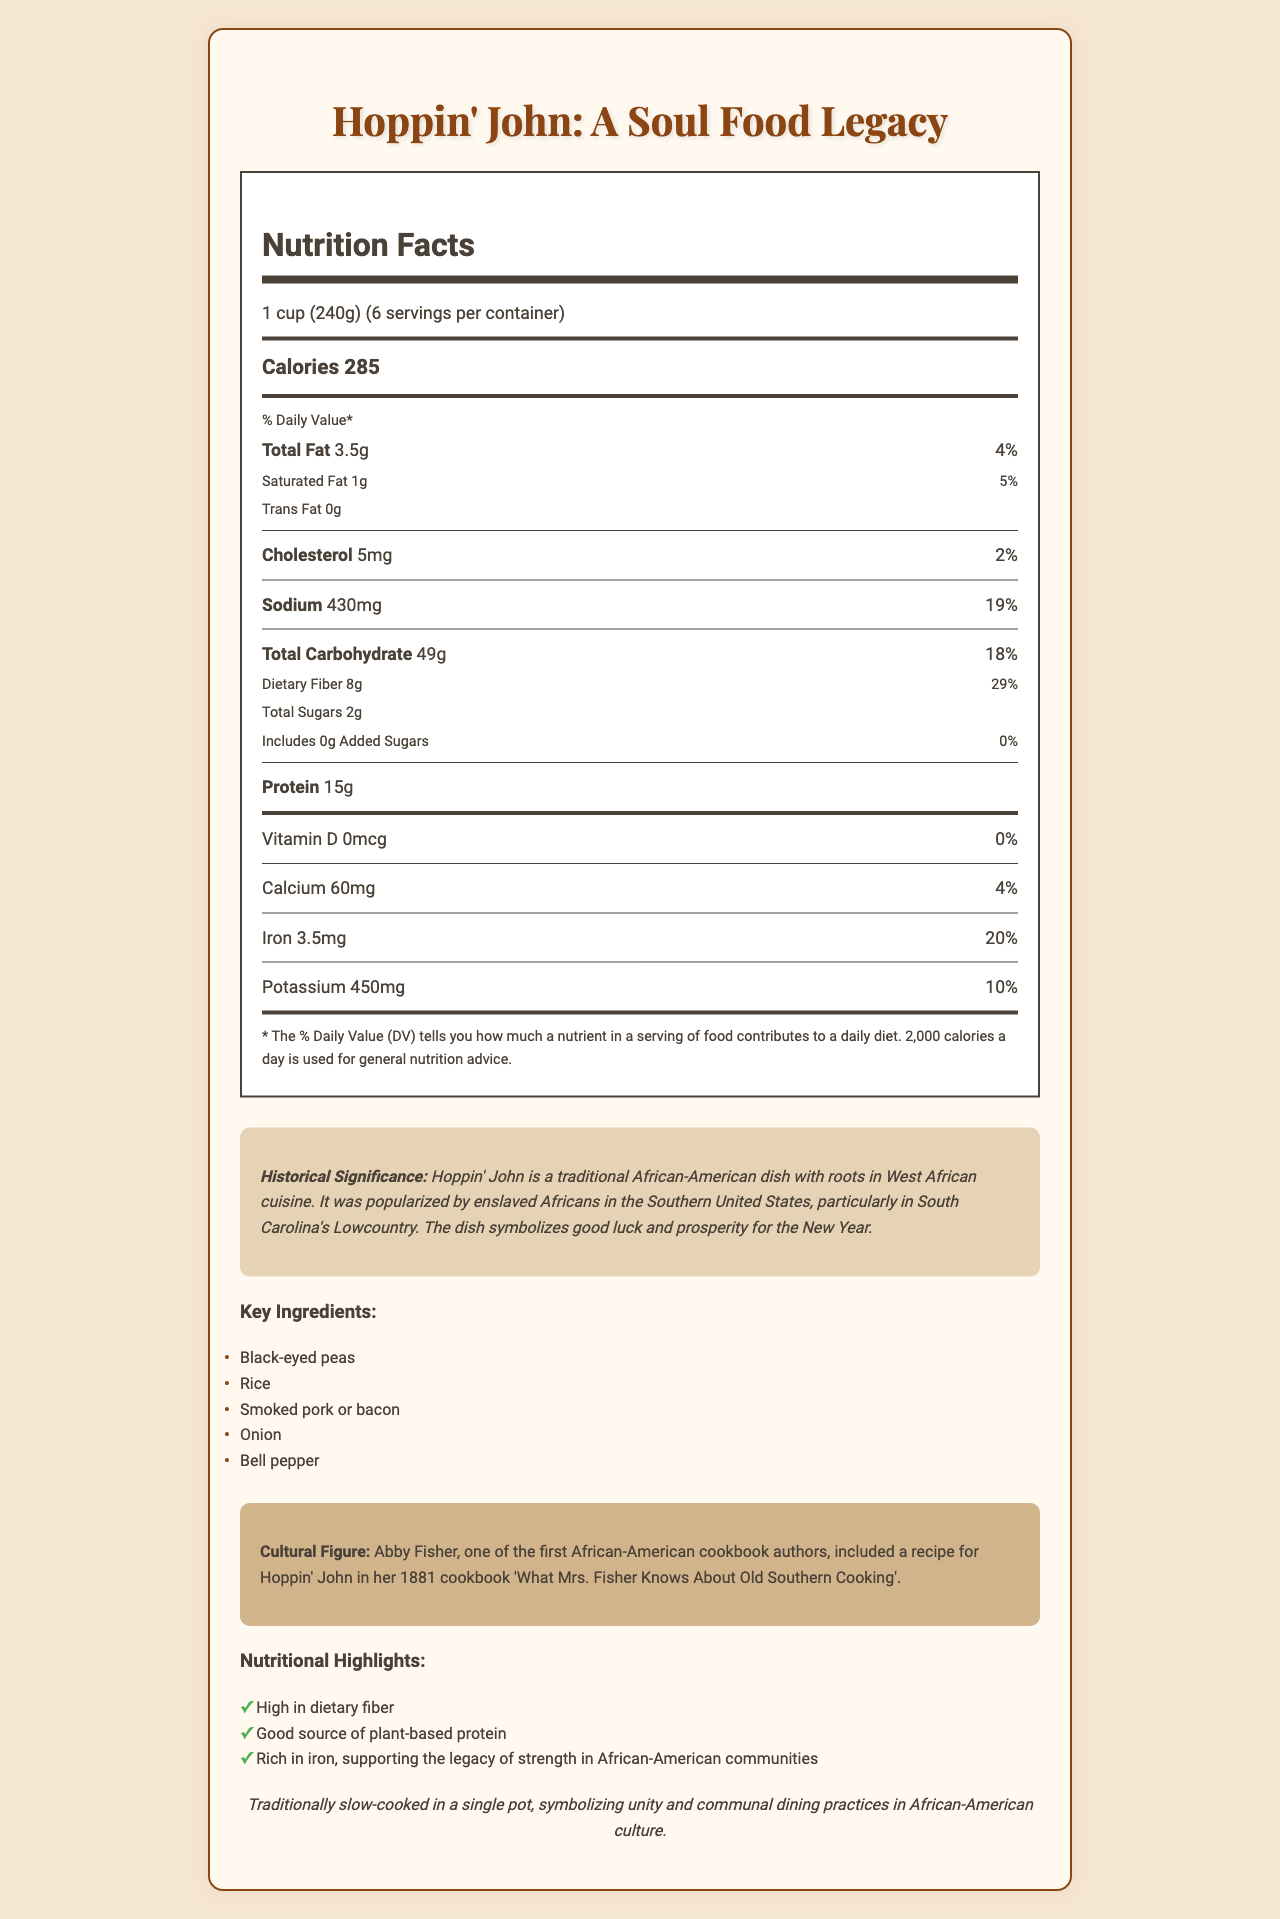what is the calorie content per serving? The document states that each serving of Hoppin' John contains 285 calories.
Answer: 285 calories how much dietary fiber is in one serving? The Nutrition Facts section shows that each serving has 8 grams of dietary fiber.
Answer: 8 grams what is the recommended daily value percentage for sodium in one serving? According to the document, one serving of Hoppin' John contains 19% of the recommended daily value for sodium.
Answer: 19% who is a notable cultural figure associated with Hoppin' John? The document mentions Abby Fisher, one of the first African-American cookbook authors, including a recipe for Hoppin' John in her 1881 cookbook.
Answer: Abby Fisher what is the suggested method of preparation for Hoppin' John? The preparation method notes that the dish is traditionally slow-cooked in a single pot.
Answer: Traditionally slow-cooked in a single pot which of the following is not an ingredient in Hoppin' John? A. Black-eyed peas B. Smoked pork C. Tomatoes D. Onions The key ingredients listed are black-eyed peas, rice, smoked pork or bacon, onion, and bell pepper. Tomatoes are not mentioned as an ingredient.
Answer: C. Tomatoes what is the amount of total fat in one serving? A. 3.5 grams B. 2 grams C. 5 grams D. 1 gram The Nutrition Facts section specifies that there are 3.5 grams of total fat per serving.
Answer: A. 3.5 grams is Hoppin' John a good source of plant-based protein? According to the nutritional highlights, Hoppin' John is noted as being a good source of plant-based protein.
Answer: Yes summarize the main idea of the document. This summary captures all key sections of the document, including nutritional information, historical context, main ingredients, and cultural significance.
Answer: The document provides nutritional facts and historical significance of Hoppin' John, a traditional African-American soul food dish. It includes serving details, ingredient list, preparation method, and notes on its cultural relevance. what is the daily value percentage for iron in one serving? The Nutrition Facts section shows that one serving contains 3.5 mg of iron, which is 20% of the daily value.
Answer: 20% what cultural value is symbolized by the preparation method of Hoppin' John? The preparation method emphasizes slow cooking in a single pot, symbolizing unity and communal dining practices in African-American culture.
Answer: Unity and communal dining practices how many servings are in one container of Hoppin' John? The document states that there are 6 servings per container.
Answer: 6 servings which nutrient does Hoppin' John not contain? A. Vitamin D B. Calcium C. Potassium D. None of the above The Nutrition Facts indicate that Hoppin' John contains 0 mcg of Vitamin D.
Answer: A. Vitamin D does the document provide the specific date when Abby Fisher included Hoppin' John in her cookbook? The document mentions that Abby Fisher included the recipe in her 1881 cookbook but does not specify a date.
Answer: No what is the amount of potassium in one serving? The Nutrition Facts label shows that each serving contains 450 mg of potassium.
Answer: 450 mg what is the historical significance of Hoppin' John? The document mentions the dish's West African roots, its popularization by enslaved Africans, and its symbolism of good luck and prosperity.
Answer: Hoppin' John is a traditional African-American dish with roots in West African cuisine, popularized by enslaved Africans in the Southern United States, symbolizing good luck and prosperity for the New Year. what is the total carbohydrate content per serving? The Nutrition Facts section lists the total carbohydrate content as 49 grams per serving.
Answer: 49 grams 